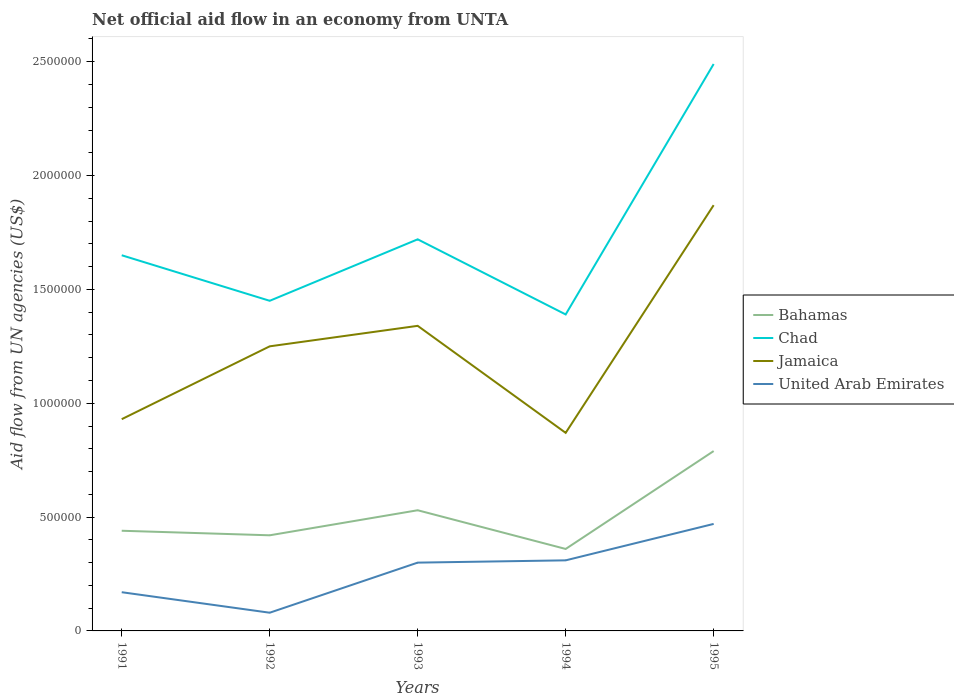How many different coloured lines are there?
Your answer should be compact. 4. Across all years, what is the maximum net official aid flow in Chad?
Ensure brevity in your answer.  1.39e+06. In which year was the net official aid flow in Chad maximum?
Make the answer very short. 1994. What is the difference between the highest and the lowest net official aid flow in Jamaica?
Provide a short and direct response. 2. Is the net official aid flow in Jamaica strictly greater than the net official aid flow in Bahamas over the years?
Your answer should be very brief. No. What is the difference between two consecutive major ticks on the Y-axis?
Provide a succinct answer. 5.00e+05. Are the values on the major ticks of Y-axis written in scientific E-notation?
Provide a short and direct response. No. Does the graph contain any zero values?
Keep it short and to the point. No. Where does the legend appear in the graph?
Your answer should be very brief. Center right. What is the title of the graph?
Make the answer very short. Net official aid flow in an economy from UNTA. Does "Cabo Verde" appear as one of the legend labels in the graph?
Make the answer very short. No. What is the label or title of the X-axis?
Give a very brief answer. Years. What is the label or title of the Y-axis?
Your answer should be compact. Aid flow from UN agencies (US$). What is the Aid flow from UN agencies (US$) in Bahamas in 1991?
Make the answer very short. 4.40e+05. What is the Aid flow from UN agencies (US$) of Chad in 1991?
Make the answer very short. 1.65e+06. What is the Aid flow from UN agencies (US$) in Jamaica in 1991?
Ensure brevity in your answer.  9.30e+05. What is the Aid flow from UN agencies (US$) of United Arab Emirates in 1991?
Provide a succinct answer. 1.70e+05. What is the Aid flow from UN agencies (US$) of Chad in 1992?
Provide a succinct answer. 1.45e+06. What is the Aid flow from UN agencies (US$) of Jamaica in 1992?
Ensure brevity in your answer.  1.25e+06. What is the Aid flow from UN agencies (US$) of United Arab Emirates in 1992?
Provide a short and direct response. 8.00e+04. What is the Aid flow from UN agencies (US$) in Bahamas in 1993?
Provide a succinct answer. 5.30e+05. What is the Aid flow from UN agencies (US$) of Chad in 1993?
Give a very brief answer. 1.72e+06. What is the Aid flow from UN agencies (US$) in Jamaica in 1993?
Give a very brief answer. 1.34e+06. What is the Aid flow from UN agencies (US$) in United Arab Emirates in 1993?
Offer a very short reply. 3.00e+05. What is the Aid flow from UN agencies (US$) of Chad in 1994?
Offer a terse response. 1.39e+06. What is the Aid flow from UN agencies (US$) in Jamaica in 1994?
Your response must be concise. 8.70e+05. What is the Aid flow from UN agencies (US$) in Bahamas in 1995?
Your answer should be very brief. 7.90e+05. What is the Aid flow from UN agencies (US$) of Chad in 1995?
Your answer should be compact. 2.49e+06. What is the Aid flow from UN agencies (US$) of Jamaica in 1995?
Your answer should be very brief. 1.87e+06. What is the Aid flow from UN agencies (US$) in United Arab Emirates in 1995?
Your answer should be compact. 4.70e+05. Across all years, what is the maximum Aid flow from UN agencies (US$) of Bahamas?
Your answer should be very brief. 7.90e+05. Across all years, what is the maximum Aid flow from UN agencies (US$) in Chad?
Make the answer very short. 2.49e+06. Across all years, what is the maximum Aid flow from UN agencies (US$) in Jamaica?
Give a very brief answer. 1.87e+06. Across all years, what is the maximum Aid flow from UN agencies (US$) in United Arab Emirates?
Keep it short and to the point. 4.70e+05. Across all years, what is the minimum Aid flow from UN agencies (US$) in Chad?
Your answer should be very brief. 1.39e+06. Across all years, what is the minimum Aid flow from UN agencies (US$) of Jamaica?
Make the answer very short. 8.70e+05. Across all years, what is the minimum Aid flow from UN agencies (US$) of United Arab Emirates?
Your response must be concise. 8.00e+04. What is the total Aid flow from UN agencies (US$) of Bahamas in the graph?
Your answer should be compact. 2.54e+06. What is the total Aid flow from UN agencies (US$) of Chad in the graph?
Provide a short and direct response. 8.70e+06. What is the total Aid flow from UN agencies (US$) in Jamaica in the graph?
Your response must be concise. 6.26e+06. What is the total Aid flow from UN agencies (US$) of United Arab Emirates in the graph?
Give a very brief answer. 1.33e+06. What is the difference between the Aid flow from UN agencies (US$) in Bahamas in 1991 and that in 1992?
Give a very brief answer. 2.00e+04. What is the difference between the Aid flow from UN agencies (US$) in Chad in 1991 and that in 1992?
Provide a succinct answer. 2.00e+05. What is the difference between the Aid flow from UN agencies (US$) in Jamaica in 1991 and that in 1992?
Provide a succinct answer. -3.20e+05. What is the difference between the Aid flow from UN agencies (US$) in United Arab Emirates in 1991 and that in 1992?
Your answer should be very brief. 9.00e+04. What is the difference between the Aid flow from UN agencies (US$) of Bahamas in 1991 and that in 1993?
Your response must be concise. -9.00e+04. What is the difference between the Aid flow from UN agencies (US$) of Jamaica in 1991 and that in 1993?
Provide a succinct answer. -4.10e+05. What is the difference between the Aid flow from UN agencies (US$) in United Arab Emirates in 1991 and that in 1994?
Give a very brief answer. -1.40e+05. What is the difference between the Aid flow from UN agencies (US$) in Bahamas in 1991 and that in 1995?
Your answer should be very brief. -3.50e+05. What is the difference between the Aid flow from UN agencies (US$) in Chad in 1991 and that in 1995?
Offer a very short reply. -8.40e+05. What is the difference between the Aid flow from UN agencies (US$) of Jamaica in 1991 and that in 1995?
Offer a very short reply. -9.40e+05. What is the difference between the Aid flow from UN agencies (US$) of Chad in 1992 and that in 1993?
Ensure brevity in your answer.  -2.70e+05. What is the difference between the Aid flow from UN agencies (US$) of Chad in 1992 and that in 1994?
Make the answer very short. 6.00e+04. What is the difference between the Aid flow from UN agencies (US$) in Bahamas in 1992 and that in 1995?
Provide a short and direct response. -3.70e+05. What is the difference between the Aid flow from UN agencies (US$) of Chad in 1992 and that in 1995?
Your response must be concise. -1.04e+06. What is the difference between the Aid flow from UN agencies (US$) in Jamaica in 1992 and that in 1995?
Your answer should be compact. -6.20e+05. What is the difference between the Aid flow from UN agencies (US$) of United Arab Emirates in 1992 and that in 1995?
Keep it short and to the point. -3.90e+05. What is the difference between the Aid flow from UN agencies (US$) of Jamaica in 1993 and that in 1994?
Make the answer very short. 4.70e+05. What is the difference between the Aid flow from UN agencies (US$) in United Arab Emirates in 1993 and that in 1994?
Keep it short and to the point. -10000. What is the difference between the Aid flow from UN agencies (US$) in Chad in 1993 and that in 1995?
Make the answer very short. -7.70e+05. What is the difference between the Aid flow from UN agencies (US$) in Jamaica in 1993 and that in 1995?
Provide a succinct answer. -5.30e+05. What is the difference between the Aid flow from UN agencies (US$) in United Arab Emirates in 1993 and that in 1995?
Offer a terse response. -1.70e+05. What is the difference between the Aid flow from UN agencies (US$) in Bahamas in 1994 and that in 1995?
Provide a succinct answer. -4.30e+05. What is the difference between the Aid flow from UN agencies (US$) of Chad in 1994 and that in 1995?
Offer a terse response. -1.10e+06. What is the difference between the Aid flow from UN agencies (US$) of Bahamas in 1991 and the Aid flow from UN agencies (US$) of Chad in 1992?
Offer a terse response. -1.01e+06. What is the difference between the Aid flow from UN agencies (US$) of Bahamas in 1991 and the Aid flow from UN agencies (US$) of Jamaica in 1992?
Ensure brevity in your answer.  -8.10e+05. What is the difference between the Aid flow from UN agencies (US$) of Bahamas in 1991 and the Aid flow from UN agencies (US$) of United Arab Emirates in 1992?
Offer a very short reply. 3.60e+05. What is the difference between the Aid flow from UN agencies (US$) of Chad in 1991 and the Aid flow from UN agencies (US$) of United Arab Emirates in 1992?
Provide a short and direct response. 1.57e+06. What is the difference between the Aid flow from UN agencies (US$) in Jamaica in 1991 and the Aid flow from UN agencies (US$) in United Arab Emirates in 1992?
Provide a short and direct response. 8.50e+05. What is the difference between the Aid flow from UN agencies (US$) of Bahamas in 1991 and the Aid flow from UN agencies (US$) of Chad in 1993?
Offer a very short reply. -1.28e+06. What is the difference between the Aid flow from UN agencies (US$) in Bahamas in 1991 and the Aid flow from UN agencies (US$) in Jamaica in 1993?
Your answer should be compact. -9.00e+05. What is the difference between the Aid flow from UN agencies (US$) in Chad in 1991 and the Aid flow from UN agencies (US$) in United Arab Emirates in 1993?
Your answer should be very brief. 1.35e+06. What is the difference between the Aid flow from UN agencies (US$) of Jamaica in 1991 and the Aid flow from UN agencies (US$) of United Arab Emirates in 1993?
Ensure brevity in your answer.  6.30e+05. What is the difference between the Aid flow from UN agencies (US$) in Bahamas in 1991 and the Aid flow from UN agencies (US$) in Chad in 1994?
Your response must be concise. -9.50e+05. What is the difference between the Aid flow from UN agencies (US$) of Bahamas in 1991 and the Aid flow from UN agencies (US$) of Jamaica in 1994?
Your answer should be very brief. -4.30e+05. What is the difference between the Aid flow from UN agencies (US$) of Chad in 1991 and the Aid flow from UN agencies (US$) of Jamaica in 1994?
Offer a terse response. 7.80e+05. What is the difference between the Aid flow from UN agencies (US$) in Chad in 1991 and the Aid flow from UN agencies (US$) in United Arab Emirates in 1994?
Provide a short and direct response. 1.34e+06. What is the difference between the Aid flow from UN agencies (US$) of Jamaica in 1991 and the Aid flow from UN agencies (US$) of United Arab Emirates in 1994?
Ensure brevity in your answer.  6.20e+05. What is the difference between the Aid flow from UN agencies (US$) in Bahamas in 1991 and the Aid flow from UN agencies (US$) in Chad in 1995?
Provide a succinct answer. -2.05e+06. What is the difference between the Aid flow from UN agencies (US$) of Bahamas in 1991 and the Aid flow from UN agencies (US$) of Jamaica in 1995?
Keep it short and to the point. -1.43e+06. What is the difference between the Aid flow from UN agencies (US$) in Chad in 1991 and the Aid flow from UN agencies (US$) in United Arab Emirates in 1995?
Provide a succinct answer. 1.18e+06. What is the difference between the Aid flow from UN agencies (US$) of Jamaica in 1991 and the Aid flow from UN agencies (US$) of United Arab Emirates in 1995?
Ensure brevity in your answer.  4.60e+05. What is the difference between the Aid flow from UN agencies (US$) of Bahamas in 1992 and the Aid flow from UN agencies (US$) of Chad in 1993?
Give a very brief answer. -1.30e+06. What is the difference between the Aid flow from UN agencies (US$) in Bahamas in 1992 and the Aid flow from UN agencies (US$) in Jamaica in 1993?
Your answer should be very brief. -9.20e+05. What is the difference between the Aid flow from UN agencies (US$) of Chad in 1992 and the Aid flow from UN agencies (US$) of Jamaica in 1993?
Offer a very short reply. 1.10e+05. What is the difference between the Aid flow from UN agencies (US$) of Chad in 1992 and the Aid flow from UN agencies (US$) of United Arab Emirates in 1993?
Provide a short and direct response. 1.15e+06. What is the difference between the Aid flow from UN agencies (US$) in Jamaica in 1992 and the Aid flow from UN agencies (US$) in United Arab Emirates in 1993?
Give a very brief answer. 9.50e+05. What is the difference between the Aid flow from UN agencies (US$) of Bahamas in 1992 and the Aid flow from UN agencies (US$) of Chad in 1994?
Offer a terse response. -9.70e+05. What is the difference between the Aid flow from UN agencies (US$) in Bahamas in 1992 and the Aid flow from UN agencies (US$) in Jamaica in 1994?
Give a very brief answer. -4.50e+05. What is the difference between the Aid flow from UN agencies (US$) in Bahamas in 1992 and the Aid flow from UN agencies (US$) in United Arab Emirates in 1994?
Provide a short and direct response. 1.10e+05. What is the difference between the Aid flow from UN agencies (US$) in Chad in 1992 and the Aid flow from UN agencies (US$) in Jamaica in 1994?
Your response must be concise. 5.80e+05. What is the difference between the Aid flow from UN agencies (US$) of Chad in 1992 and the Aid flow from UN agencies (US$) of United Arab Emirates in 1994?
Keep it short and to the point. 1.14e+06. What is the difference between the Aid flow from UN agencies (US$) in Jamaica in 1992 and the Aid flow from UN agencies (US$) in United Arab Emirates in 1994?
Offer a terse response. 9.40e+05. What is the difference between the Aid flow from UN agencies (US$) in Bahamas in 1992 and the Aid flow from UN agencies (US$) in Chad in 1995?
Your answer should be compact. -2.07e+06. What is the difference between the Aid flow from UN agencies (US$) in Bahamas in 1992 and the Aid flow from UN agencies (US$) in Jamaica in 1995?
Provide a succinct answer. -1.45e+06. What is the difference between the Aid flow from UN agencies (US$) in Bahamas in 1992 and the Aid flow from UN agencies (US$) in United Arab Emirates in 1995?
Your answer should be very brief. -5.00e+04. What is the difference between the Aid flow from UN agencies (US$) in Chad in 1992 and the Aid flow from UN agencies (US$) in Jamaica in 1995?
Your answer should be compact. -4.20e+05. What is the difference between the Aid flow from UN agencies (US$) of Chad in 1992 and the Aid flow from UN agencies (US$) of United Arab Emirates in 1995?
Offer a terse response. 9.80e+05. What is the difference between the Aid flow from UN agencies (US$) in Jamaica in 1992 and the Aid flow from UN agencies (US$) in United Arab Emirates in 1995?
Your answer should be very brief. 7.80e+05. What is the difference between the Aid flow from UN agencies (US$) in Bahamas in 1993 and the Aid flow from UN agencies (US$) in Chad in 1994?
Your response must be concise. -8.60e+05. What is the difference between the Aid flow from UN agencies (US$) in Bahamas in 1993 and the Aid flow from UN agencies (US$) in Jamaica in 1994?
Your response must be concise. -3.40e+05. What is the difference between the Aid flow from UN agencies (US$) of Bahamas in 1993 and the Aid flow from UN agencies (US$) of United Arab Emirates in 1994?
Offer a terse response. 2.20e+05. What is the difference between the Aid flow from UN agencies (US$) of Chad in 1993 and the Aid flow from UN agencies (US$) of Jamaica in 1994?
Offer a terse response. 8.50e+05. What is the difference between the Aid flow from UN agencies (US$) of Chad in 1993 and the Aid flow from UN agencies (US$) of United Arab Emirates in 1994?
Give a very brief answer. 1.41e+06. What is the difference between the Aid flow from UN agencies (US$) in Jamaica in 1993 and the Aid flow from UN agencies (US$) in United Arab Emirates in 1994?
Your answer should be compact. 1.03e+06. What is the difference between the Aid flow from UN agencies (US$) of Bahamas in 1993 and the Aid flow from UN agencies (US$) of Chad in 1995?
Offer a very short reply. -1.96e+06. What is the difference between the Aid flow from UN agencies (US$) of Bahamas in 1993 and the Aid flow from UN agencies (US$) of Jamaica in 1995?
Ensure brevity in your answer.  -1.34e+06. What is the difference between the Aid flow from UN agencies (US$) in Bahamas in 1993 and the Aid flow from UN agencies (US$) in United Arab Emirates in 1995?
Offer a terse response. 6.00e+04. What is the difference between the Aid flow from UN agencies (US$) in Chad in 1993 and the Aid flow from UN agencies (US$) in United Arab Emirates in 1995?
Keep it short and to the point. 1.25e+06. What is the difference between the Aid flow from UN agencies (US$) of Jamaica in 1993 and the Aid flow from UN agencies (US$) of United Arab Emirates in 1995?
Your answer should be compact. 8.70e+05. What is the difference between the Aid flow from UN agencies (US$) in Bahamas in 1994 and the Aid flow from UN agencies (US$) in Chad in 1995?
Offer a very short reply. -2.13e+06. What is the difference between the Aid flow from UN agencies (US$) in Bahamas in 1994 and the Aid flow from UN agencies (US$) in Jamaica in 1995?
Your answer should be very brief. -1.51e+06. What is the difference between the Aid flow from UN agencies (US$) of Chad in 1994 and the Aid flow from UN agencies (US$) of Jamaica in 1995?
Your response must be concise. -4.80e+05. What is the difference between the Aid flow from UN agencies (US$) of Chad in 1994 and the Aid flow from UN agencies (US$) of United Arab Emirates in 1995?
Provide a short and direct response. 9.20e+05. What is the average Aid flow from UN agencies (US$) in Bahamas per year?
Your answer should be compact. 5.08e+05. What is the average Aid flow from UN agencies (US$) in Chad per year?
Your answer should be very brief. 1.74e+06. What is the average Aid flow from UN agencies (US$) of Jamaica per year?
Offer a terse response. 1.25e+06. What is the average Aid flow from UN agencies (US$) of United Arab Emirates per year?
Provide a succinct answer. 2.66e+05. In the year 1991, what is the difference between the Aid flow from UN agencies (US$) of Bahamas and Aid flow from UN agencies (US$) of Chad?
Give a very brief answer. -1.21e+06. In the year 1991, what is the difference between the Aid flow from UN agencies (US$) of Bahamas and Aid flow from UN agencies (US$) of Jamaica?
Your answer should be compact. -4.90e+05. In the year 1991, what is the difference between the Aid flow from UN agencies (US$) of Bahamas and Aid flow from UN agencies (US$) of United Arab Emirates?
Keep it short and to the point. 2.70e+05. In the year 1991, what is the difference between the Aid flow from UN agencies (US$) of Chad and Aid flow from UN agencies (US$) of Jamaica?
Your response must be concise. 7.20e+05. In the year 1991, what is the difference between the Aid flow from UN agencies (US$) of Chad and Aid flow from UN agencies (US$) of United Arab Emirates?
Give a very brief answer. 1.48e+06. In the year 1991, what is the difference between the Aid flow from UN agencies (US$) in Jamaica and Aid flow from UN agencies (US$) in United Arab Emirates?
Offer a very short reply. 7.60e+05. In the year 1992, what is the difference between the Aid flow from UN agencies (US$) of Bahamas and Aid flow from UN agencies (US$) of Chad?
Offer a terse response. -1.03e+06. In the year 1992, what is the difference between the Aid flow from UN agencies (US$) of Bahamas and Aid flow from UN agencies (US$) of Jamaica?
Ensure brevity in your answer.  -8.30e+05. In the year 1992, what is the difference between the Aid flow from UN agencies (US$) of Bahamas and Aid flow from UN agencies (US$) of United Arab Emirates?
Your response must be concise. 3.40e+05. In the year 1992, what is the difference between the Aid flow from UN agencies (US$) of Chad and Aid flow from UN agencies (US$) of United Arab Emirates?
Offer a terse response. 1.37e+06. In the year 1992, what is the difference between the Aid flow from UN agencies (US$) in Jamaica and Aid flow from UN agencies (US$) in United Arab Emirates?
Give a very brief answer. 1.17e+06. In the year 1993, what is the difference between the Aid flow from UN agencies (US$) in Bahamas and Aid flow from UN agencies (US$) in Chad?
Give a very brief answer. -1.19e+06. In the year 1993, what is the difference between the Aid flow from UN agencies (US$) of Bahamas and Aid flow from UN agencies (US$) of Jamaica?
Your response must be concise. -8.10e+05. In the year 1993, what is the difference between the Aid flow from UN agencies (US$) in Bahamas and Aid flow from UN agencies (US$) in United Arab Emirates?
Your answer should be compact. 2.30e+05. In the year 1993, what is the difference between the Aid flow from UN agencies (US$) of Chad and Aid flow from UN agencies (US$) of United Arab Emirates?
Give a very brief answer. 1.42e+06. In the year 1993, what is the difference between the Aid flow from UN agencies (US$) in Jamaica and Aid flow from UN agencies (US$) in United Arab Emirates?
Your answer should be very brief. 1.04e+06. In the year 1994, what is the difference between the Aid flow from UN agencies (US$) of Bahamas and Aid flow from UN agencies (US$) of Chad?
Keep it short and to the point. -1.03e+06. In the year 1994, what is the difference between the Aid flow from UN agencies (US$) of Bahamas and Aid flow from UN agencies (US$) of Jamaica?
Your answer should be very brief. -5.10e+05. In the year 1994, what is the difference between the Aid flow from UN agencies (US$) in Chad and Aid flow from UN agencies (US$) in Jamaica?
Your response must be concise. 5.20e+05. In the year 1994, what is the difference between the Aid flow from UN agencies (US$) of Chad and Aid flow from UN agencies (US$) of United Arab Emirates?
Keep it short and to the point. 1.08e+06. In the year 1994, what is the difference between the Aid flow from UN agencies (US$) in Jamaica and Aid flow from UN agencies (US$) in United Arab Emirates?
Your response must be concise. 5.60e+05. In the year 1995, what is the difference between the Aid flow from UN agencies (US$) of Bahamas and Aid flow from UN agencies (US$) of Chad?
Keep it short and to the point. -1.70e+06. In the year 1995, what is the difference between the Aid flow from UN agencies (US$) of Bahamas and Aid flow from UN agencies (US$) of Jamaica?
Offer a terse response. -1.08e+06. In the year 1995, what is the difference between the Aid flow from UN agencies (US$) in Bahamas and Aid flow from UN agencies (US$) in United Arab Emirates?
Keep it short and to the point. 3.20e+05. In the year 1995, what is the difference between the Aid flow from UN agencies (US$) in Chad and Aid flow from UN agencies (US$) in Jamaica?
Keep it short and to the point. 6.20e+05. In the year 1995, what is the difference between the Aid flow from UN agencies (US$) in Chad and Aid flow from UN agencies (US$) in United Arab Emirates?
Offer a terse response. 2.02e+06. In the year 1995, what is the difference between the Aid flow from UN agencies (US$) of Jamaica and Aid flow from UN agencies (US$) of United Arab Emirates?
Provide a succinct answer. 1.40e+06. What is the ratio of the Aid flow from UN agencies (US$) in Bahamas in 1991 to that in 1992?
Offer a very short reply. 1.05. What is the ratio of the Aid flow from UN agencies (US$) of Chad in 1991 to that in 1992?
Make the answer very short. 1.14. What is the ratio of the Aid flow from UN agencies (US$) in Jamaica in 1991 to that in 1992?
Make the answer very short. 0.74. What is the ratio of the Aid flow from UN agencies (US$) in United Arab Emirates in 1991 to that in 1992?
Offer a terse response. 2.12. What is the ratio of the Aid flow from UN agencies (US$) of Bahamas in 1991 to that in 1993?
Ensure brevity in your answer.  0.83. What is the ratio of the Aid flow from UN agencies (US$) of Chad in 1991 to that in 1993?
Keep it short and to the point. 0.96. What is the ratio of the Aid flow from UN agencies (US$) of Jamaica in 1991 to that in 1993?
Your answer should be compact. 0.69. What is the ratio of the Aid flow from UN agencies (US$) in United Arab Emirates in 1991 to that in 1993?
Ensure brevity in your answer.  0.57. What is the ratio of the Aid flow from UN agencies (US$) in Bahamas in 1991 to that in 1994?
Make the answer very short. 1.22. What is the ratio of the Aid flow from UN agencies (US$) in Chad in 1991 to that in 1994?
Ensure brevity in your answer.  1.19. What is the ratio of the Aid flow from UN agencies (US$) of Jamaica in 1991 to that in 1994?
Your response must be concise. 1.07. What is the ratio of the Aid flow from UN agencies (US$) of United Arab Emirates in 1991 to that in 1994?
Offer a very short reply. 0.55. What is the ratio of the Aid flow from UN agencies (US$) in Bahamas in 1991 to that in 1995?
Your answer should be very brief. 0.56. What is the ratio of the Aid flow from UN agencies (US$) of Chad in 1991 to that in 1995?
Your response must be concise. 0.66. What is the ratio of the Aid flow from UN agencies (US$) in Jamaica in 1991 to that in 1995?
Your answer should be compact. 0.5. What is the ratio of the Aid flow from UN agencies (US$) of United Arab Emirates in 1991 to that in 1995?
Make the answer very short. 0.36. What is the ratio of the Aid flow from UN agencies (US$) in Bahamas in 1992 to that in 1993?
Make the answer very short. 0.79. What is the ratio of the Aid flow from UN agencies (US$) in Chad in 1992 to that in 1993?
Provide a succinct answer. 0.84. What is the ratio of the Aid flow from UN agencies (US$) in Jamaica in 1992 to that in 1993?
Your answer should be compact. 0.93. What is the ratio of the Aid flow from UN agencies (US$) of United Arab Emirates in 1992 to that in 1993?
Ensure brevity in your answer.  0.27. What is the ratio of the Aid flow from UN agencies (US$) in Chad in 1992 to that in 1994?
Offer a terse response. 1.04. What is the ratio of the Aid flow from UN agencies (US$) in Jamaica in 1992 to that in 1994?
Your answer should be compact. 1.44. What is the ratio of the Aid flow from UN agencies (US$) in United Arab Emirates in 1992 to that in 1994?
Your response must be concise. 0.26. What is the ratio of the Aid flow from UN agencies (US$) of Bahamas in 1992 to that in 1995?
Give a very brief answer. 0.53. What is the ratio of the Aid flow from UN agencies (US$) in Chad in 1992 to that in 1995?
Offer a very short reply. 0.58. What is the ratio of the Aid flow from UN agencies (US$) in Jamaica in 1992 to that in 1995?
Give a very brief answer. 0.67. What is the ratio of the Aid flow from UN agencies (US$) of United Arab Emirates in 1992 to that in 1995?
Offer a terse response. 0.17. What is the ratio of the Aid flow from UN agencies (US$) of Bahamas in 1993 to that in 1994?
Provide a short and direct response. 1.47. What is the ratio of the Aid flow from UN agencies (US$) in Chad in 1993 to that in 1994?
Your answer should be very brief. 1.24. What is the ratio of the Aid flow from UN agencies (US$) of Jamaica in 1993 to that in 1994?
Provide a succinct answer. 1.54. What is the ratio of the Aid flow from UN agencies (US$) of United Arab Emirates in 1993 to that in 1994?
Your answer should be compact. 0.97. What is the ratio of the Aid flow from UN agencies (US$) of Bahamas in 1993 to that in 1995?
Offer a very short reply. 0.67. What is the ratio of the Aid flow from UN agencies (US$) in Chad in 1993 to that in 1995?
Provide a succinct answer. 0.69. What is the ratio of the Aid flow from UN agencies (US$) in Jamaica in 1993 to that in 1995?
Your answer should be compact. 0.72. What is the ratio of the Aid flow from UN agencies (US$) of United Arab Emirates in 1993 to that in 1995?
Ensure brevity in your answer.  0.64. What is the ratio of the Aid flow from UN agencies (US$) in Bahamas in 1994 to that in 1995?
Offer a very short reply. 0.46. What is the ratio of the Aid flow from UN agencies (US$) in Chad in 1994 to that in 1995?
Offer a terse response. 0.56. What is the ratio of the Aid flow from UN agencies (US$) of Jamaica in 1994 to that in 1995?
Your response must be concise. 0.47. What is the ratio of the Aid flow from UN agencies (US$) in United Arab Emirates in 1994 to that in 1995?
Ensure brevity in your answer.  0.66. What is the difference between the highest and the second highest Aid flow from UN agencies (US$) in Bahamas?
Your answer should be compact. 2.60e+05. What is the difference between the highest and the second highest Aid flow from UN agencies (US$) of Chad?
Your answer should be very brief. 7.70e+05. What is the difference between the highest and the second highest Aid flow from UN agencies (US$) in Jamaica?
Offer a very short reply. 5.30e+05. What is the difference between the highest and the second highest Aid flow from UN agencies (US$) in United Arab Emirates?
Your response must be concise. 1.60e+05. What is the difference between the highest and the lowest Aid flow from UN agencies (US$) in Chad?
Offer a terse response. 1.10e+06. What is the difference between the highest and the lowest Aid flow from UN agencies (US$) of Jamaica?
Ensure brevity in your answer.  1.00e+06. What is the difference between the highest and the lowest Aid flow from UN agencies (US$) in United Arab Emirates?
Your answer should be very brief. 3.90e+05. 